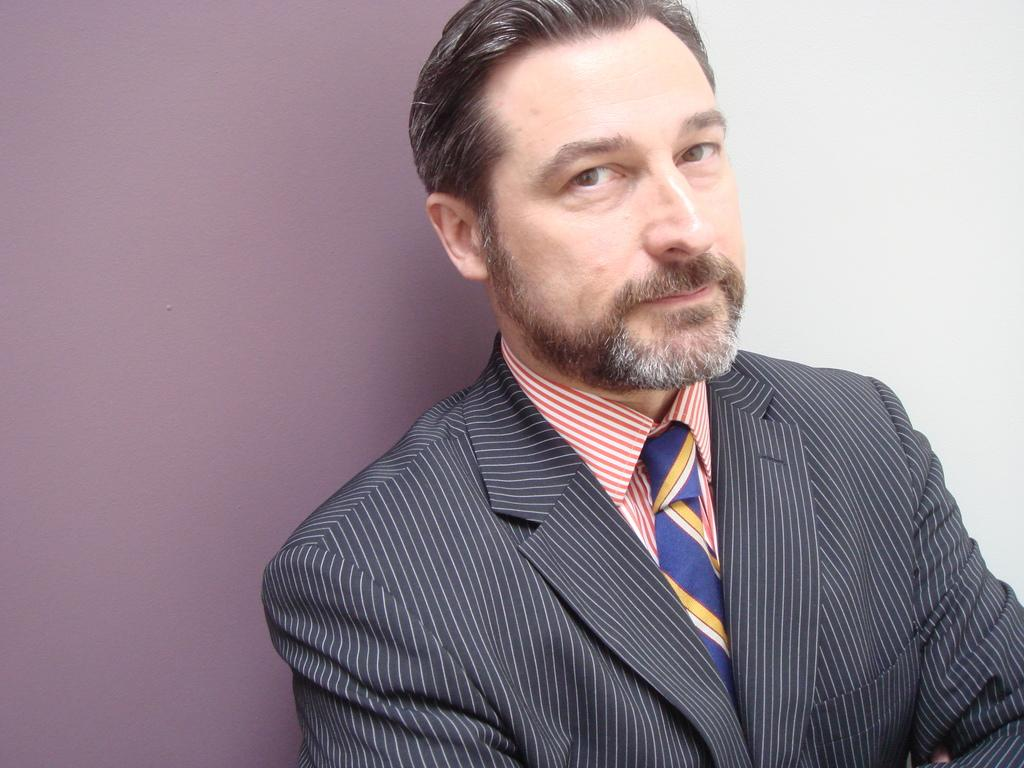Who is present in the image? There is a man in the image. What is behind the man in the image? There is a wall behind the man in the image. What type of leaf is the man holding in the image? There is no leaf present in the image; the man is not holding anything. 